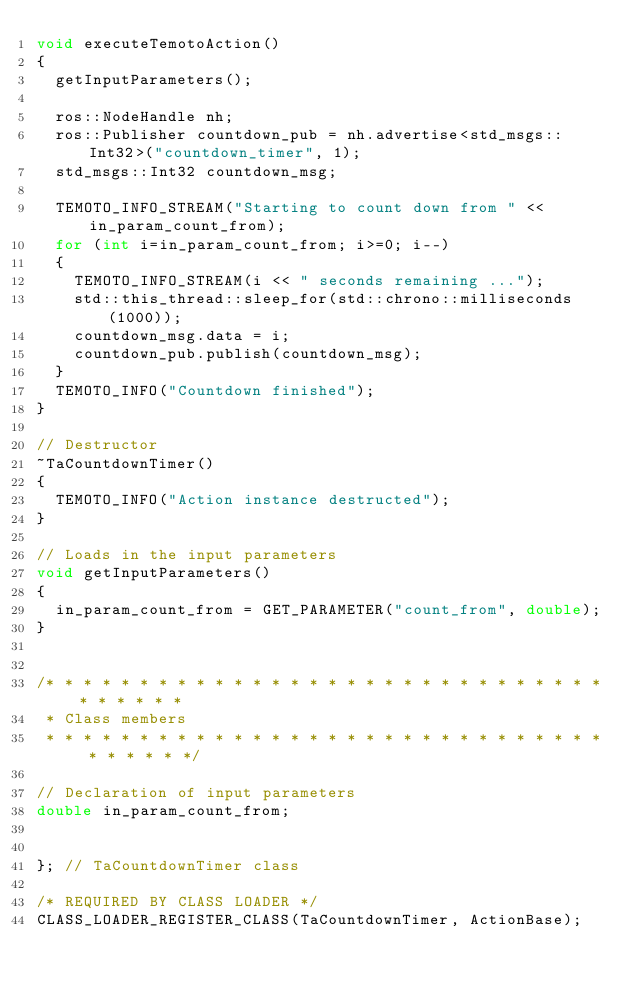<code> <loc_0><loc_0><loc_500><loc_500><_C++_>void executeTemotoAction()
{
  getInputParameters();

  ros::NodeHandle nh;
  ros::Publisher countdown_pub = nh.advertise<std_msgs::Int32>("countdown_timer", 1);
  std_msgs::Int32 countdown_msg;

  TEMOTO_INFO_STREAM("Starting to count down from " << in_param_count_from);
  for (int i=in_param_count_from; i>=0; i--)
  {
    TEMOTO_INFO_STREAM(i << " seconds remaining ...");
    std::this_thread::sleep_for(std::chrono::milliseconds(1000));
    countdown_msg.data = i;
    countdown_pub.publish(countdown_msg);
  }
  TEMOTO_INFO("Countdown finished");
}

// Destructor
~TaCountdownTimer()
{
  TEMOTO_INFO("Action instance destructed");
}

// Loads in the input parameters
void getInputParameters()
{
  in_param_count_from = GET_PARAMETER("count_from", double);
}


/* * * * * * * * * * * * * * * * * * * * * * * * * * * * * * * * * * * * 
 * Class members
 * * * * * * * * * * * * * * * * * * * * * * * * * * * * * * * * * * * */

// Declaration of input parameters
double in_param_count_from;


}; // TaCountdownTimer class

/* REQUIRED BY CLASS LOADER */
CLASS_LOADER_REGISTER_CLASS(TaCountdownTimer, ActionBase);
</code> 